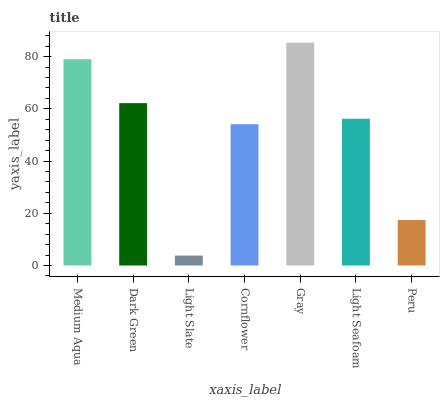Is Dark Green the minimum?
Answer yes or no. No. Is Dark Green the maximum?
Answer yes or no. No. Is Medium Aqua greater than Dark Green?
Answer yes or no. Yes. Is Dark Green less than Medium Aqua?
Answer yes or no. Yes. Is Dark Green greater than Medium Aqua?
Answer yes or no. No. Is Medium Aqua less than Dark Green?
Answer yes or no. No. Is Light Seafoam the high median?
Answer yes or no. Yes. Is Light Seafoam the low median?
Answer yes or no. Yes. Is Peru the high median?
Answer yes or no. No. Is Light Slate the low median?
Answer yes or no. No. 